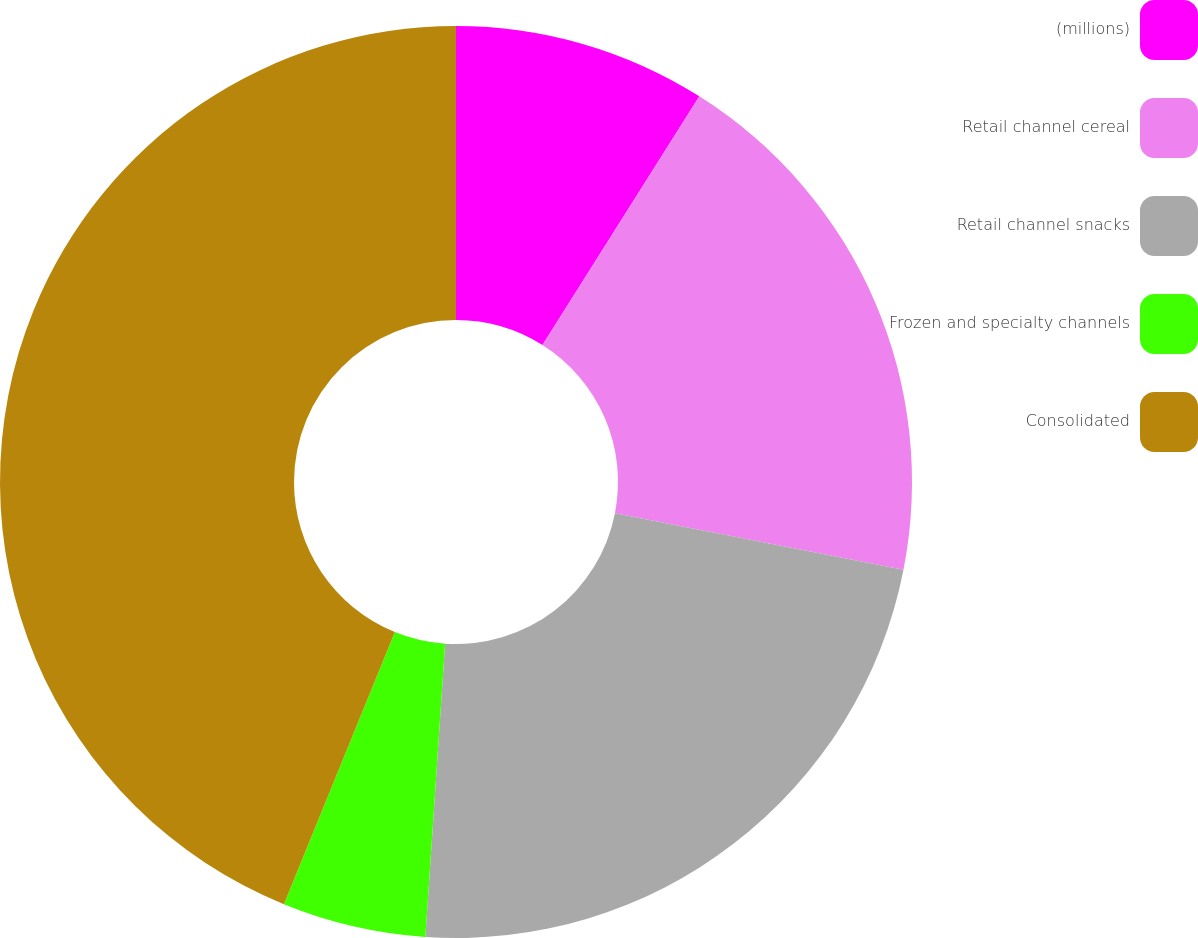Convert chart to OTSL. <chart><loc_0><loc_0><loc_500><loc_500><pie_chart><fcel>(millions)<fcel>Retail channel cereal<fcel>Retail channel snacks<fcel>Frozen and specialty channels<fcel>Consolidated<nl><fcel>8.96%<fcel>19.12%<fcel>22.99%<fcel>5.09%<fcel>43.84%<nl></chart> 